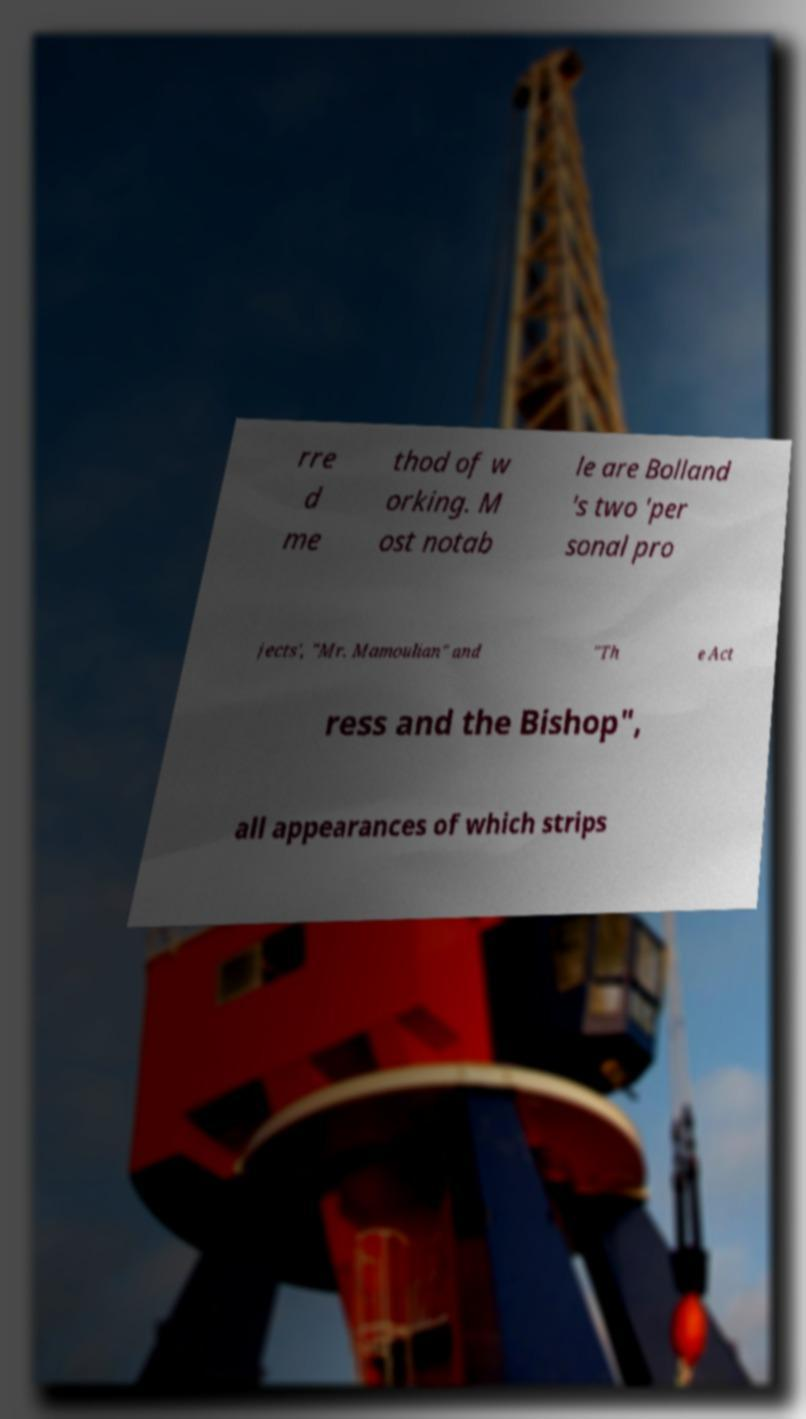For documentation purposes, I need the text within this image transcribed. Could you provide that? rre d me thod of w orking. M ost notab le are Bolland 's two 'per sonal pro jects', "Mr. Mamoulian" and "Th e Act ress and the Bishop", all appearances of which strips 